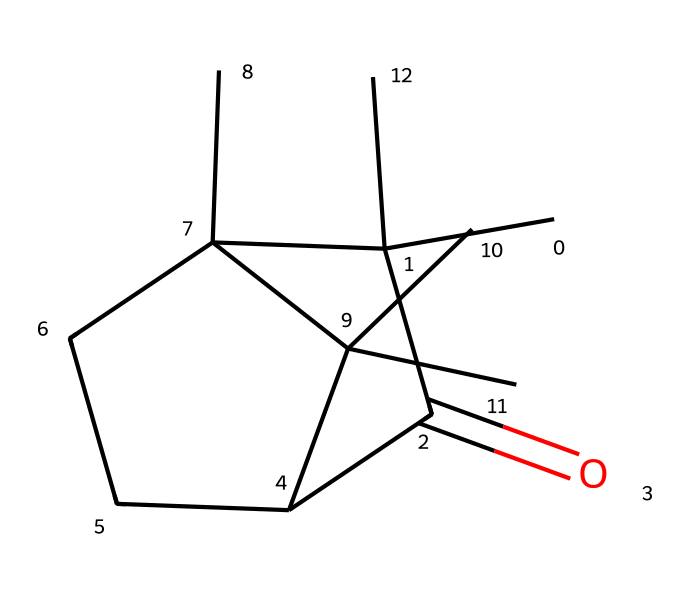What is the molecular formula of camphor? The SMILES representation can be parsed to identify the types and counts of atoms. Counting carbons (C), oxygens (O), and hydrogens (H) from the structure gives us the molecular formula C10H16O.
Answer: C10H16O How many carbon atoms are in camphor? By analyzing the SMILES structure, we find ten distinct carbon atoms represented in the structure.
Answer: 10 What type of functional group is present in camphor? Observing the structure, we see a carbonyl (C=O) group, which indicates the presence of a ketone functional group in camphor.
Answer: ketone Does camphor contain any rings in its structure? The given SMILES shows cyclical connections between carbon atoms, indicating that there are at least two rings present in the camphor structure.
Answer: yes What is a common use of camphor? Camphor is widely used as a preservative, notably in vintage textiles, due to its ability to repel insects and mold.
Answer: preservative Is camphor a primary, secondary, or tertiary alcohol? The structure shows no alcohol groups (−OH), but with regard to the functional development, it is categorized primarily as a ketone. Therefore, considering it doesn't fit the alcohol categories, it does not apply to this question contextually.
Answer: none How does the stereochemistry of camphor contribute to its properties? The specific configuration of the molecules due to the three-dimensional arrangement of its atoms influences properties such as smell and solubility, but a precise chiral center can indicate its stereoisomerism influence. Thus, it inherently provides distinct aroma and bioactivity.
Answer: influences aroma 